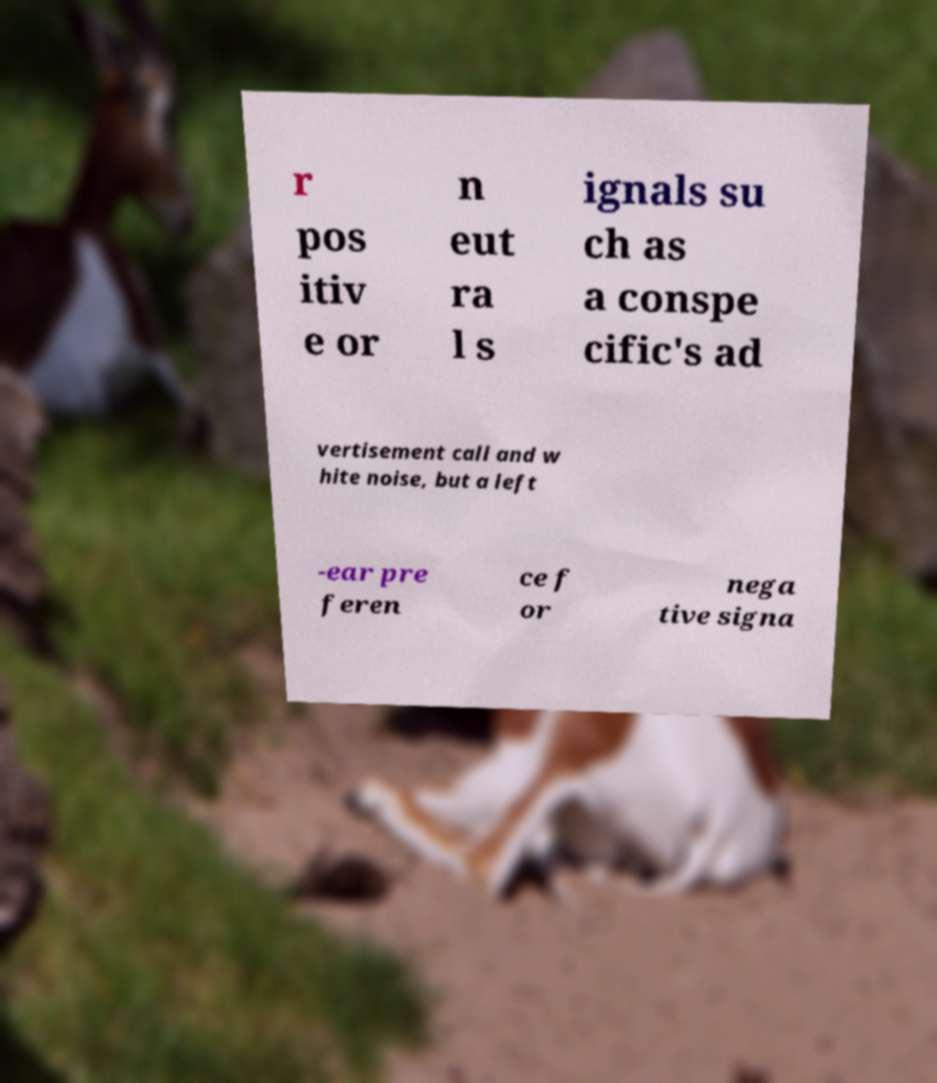There's text embedded in this image that I need extracted. Can you transcribe it verbatim? r pos itiv e or n eut ra l s ignals su ch as a conspe cific's ad vertisement call and w hite noise, but a left -ear pre feren ce f or nega tive signa 